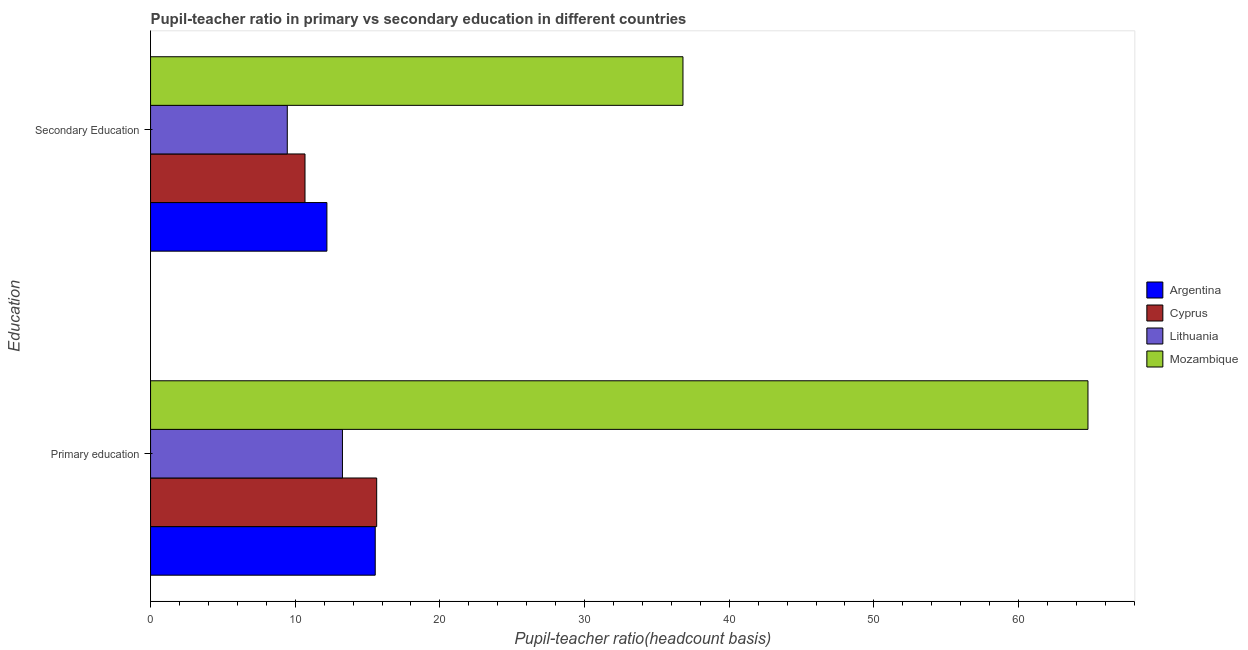Are the number of bars per tick equal to the number of legend labels?
Provide a short and direct response. Yes. Are the number of bars on each tick of the Y-axis equal?
Offer a terse response. Yes. How many bars are there on the 1st tick from the top?
Offer a terse response. 4. How many bars are there on the 2nd tick from the bottom?
Give a very brief answer. 4. What is the label of the 1st group of bars from the top?
Your answer should be compact. Secondary Education. What is the pupil-teacher ratio in primary education in Cyprus?
Provide a short and direct response. 15.63. Across all countries, what is the maximum pupil-teacher ratio in primary education?
Your answer should be very brief. 64.8. Across all countries, what is the minimum pupil-teacher ratio in primary education?
Ensure brevity in your answer.  13.26. In which country was the pupil teacher ratio on secondary education maximum?
Provide a succinct answer. Mozambique. In which country was the pupil teacher ratio on secondary education minimum?
Give a very brief answer. Lithuania. What is the total pupil-teacher ratio in primary education in the graph?
Offer a terse response. 109.22. What is the difference between the pupil-teacher ratio in primary education in Argentina and that in Cyprus?
Give a very brief answer. -0.1. What is the difference between the pupil teacher ratio on secondary education in Lithuania and the pupil-teacher ratio in primary education in Argentina?
Offer a very short reply. -6.08. What is the average pupil teacher ratio on secondary education per country?
Offer a very short reply. 17.28. What is the difference between the pupil-teacher ratio in primary education and pupil teacher ratio on secondary education in Mozambique?
Offer a terse response. 27.99. In how many countries, is the pupil-teacher ratio in primary education greater than 8 ?
Your response must be concise. 4. What is the ratio of the pupil teacher ratio on secondary education in Mozambique to that in Cyprus?
Give a very brief answer. 3.45. What does the 3rd bar from the top in Primary education represents?
Give a very brief answer. Cyprus. What does the 3rd bar from the bottom in Secondary Education represents?
Make the answer very short. Lithuania. How many bars are there?
Offer a terse response. 8. Are all the bars in the graph horizontal?
Provide a succinct answer. Yes. What is the difference between two consecutive major ticks on the X-axis?
Provide a succinct answer. 10. Does the graph contain grids?
Provide a succinct answer. No. Where does the legend appear in the graph?
Ensure brevity in your answer.  Center right. What is the title of the graph?
Give a very brief answer. Pupil-teacher ratio in primary vs secondary education in different countries. What is the label or title of the X-axis?
Your answer should be compact. Pupil-teacher ratio(headcount basis). What is the label or title of the Y-axis?
Your response must be concise. Education. What is the Pupil-teacher ratio(headcount basis) of Argentina in Primary education?
Your response must be concise. 15.53. What is the Pupil-teacher ratio(headcount basis) in Cyprus in Primary education?
Your answer should be compact. 15.63. What is the Pupil-teacher ratio(headcount basis) of Lithuania in Primary education?
Make the answer very short. 13.26. What is the Pupil-teacher ratio(headcount basis) in Mozambique in Primary education?
Offer a very short reply. 64.8. What is the Pupil-teacher ratio(headcount basis) in Argentina in Secondary Education?
Your response must be concise. 12.19. What is the Pupil-teacher ratio(headcount basis) of Cyprus in Secondary Education?
Make the answer very short. 10.68. What is the Pupil-teacher ratio(headcount basis) of Lithuania in Secondary Education?
Provide a succinct answer. 9.45. What is the Pupil-teacher ratio(headcount basis) of Mozambique in Secondary Education?
Your answer should be very brief. 36.8. Across all Education, what is the maximum Pupil-teacher ratio(headcount basis) of Argentina?
Offer a very short reply. 15.53. Across all Education, what is the maximum Pupil-teacher ratio(headcount basis) in Cyprus?
Offer a very short reply. 15.63. Across all Education, what is the maximum Pupil-teacher ratio(headcount basis) in Lithuania?
Make the answer very short. 13.26. Across all Education, what is the maximum Pupil-teacher ratio(headcount basis) in Mozambique?
Keep it short and to the point. 64.8. Across all Education, what is the minimum Pupil-teacher ratio(headcount basis) of Argentina?
Your answer should be compact. 12.19. Across all Education, what is the minimum Pupil-teacher ratio(headcount basis) in Cyprus?
Offer a very short reply. 10.68. Across all Education, what is the minimum Pupil-teacher ratio(headcount basis) of Lithuania?
Your answer should be compact. 9.45. Across all Education, what is the minimum Pupil-teacher ratio(headcount basis) in Mozambique?
Keep it short and to the point. 36.8. What is the total Pupil-teacher ratio(headcount basis) of Argentina in the graph?
Give a very brief answer. 27.72. What is the total Pupil-teacher ratio(headcount basis) of Cyprus in the graph?
Offer a very short reply. 26.31. What is the total Pupil-teacher ratio(headcount basis) of Lithuania in the graph?
Make the answer very short. 22.71. What is the total Pupil-teacher ratio(headcount basis) in Mozambique in the graph?
Offer a very short reply. 101.6. What is the difference between the Pupil-teacher ratio(headcount basis) in Argentina in Primary education and that in Secondary Education?
Ensure brevity in your answer.  3.34. What is the difference between the Pupil-teacher ratio(headcount basis) of Cyprus in Primary education and that in Secondary Education?
Provide a succinct answer. 4.95. What is the difference between the Pupil-teacher ratio(headcount basis) of Lithuania in Primary education and that in Secondary Education?
Provide a short and direct response. 3.81. What is the difference between the Pupil-teacher ratio(headcount basis) of Mozambique in Primary education and that in Secondary Education?
Give a very brief answer. 27.99. What is the difference between the Pupil-teacher ratio(headcount basis) of Argentina in Primary education and the Pupil-teacher ratio(headcount basis) of Cyprus in Secondary Education?
Your answer should be compact. 4.85. What is the difference between the Pupil-teacher ratio(headcount basis) in Argentina in Primary education and the Pupil-teacher ratio(headcount basis) in Lithuania in Secondary Education?
Offer a very short reply. 6.08. What is the difference between the Pupil-teacher ratio(headcount basis) of Argentina in Primary education and the Pupil-teacher ratio(headcount basis) of Mozambique in Secondary Education?
Your answer should be compact. -21.27. What is the difference between the Pupil-teacher ratio(headcount basis) in Cyprus in Primary education and the Pupil-teacher ratio(headcount basis) in Lithuania in Secondary Education?
Give a very brief answer. 6.18. What is the difference between the Pupil-teacher ratio(headcount basis) of Cyprus in Primary education and the Pupil-teacher ratio(headcount basis) of Mozambique in Secondary Education?
Your response must be concise. -21.17. What is the difference between the Pupil-teacher ratio(headcount basis) in Lithuania in Primary education and the Pupil-teacher ratio(headcount basis) in Mozambique in Secondary Education?
Offer a very short reply. -23.54. What is the average Pupil-teacher ratio(headcount basis) in Argentina per Education?
Offer a very short reply. 13.86. What is the average Pupil-teacher ratio(headcount basis) of Cyprus per Education?
Offer a terse response. 13.15. What is the average Pupil-teacher ratio(headcount basis) of Lithuania per Education?
Ensure brevity in your answer.  11.36. What is the average Pupil-teacher ratio(headcount basis) of Mozambique per Education?
Your answer should be very brief. 50.8. What is the difference between the Pupil-teacher ratio(headcount basis) in Argentina and Pupil-teacher ratio(headcount basis) in Cyprus in Primary education?
Your response must be concise. -0.1. What is the difference between the Pupil-teacher ratio(headcount basis) in Argentina and Pupil-teacher ratio(headcount basis) in Lithuania in Primary education?
Provide a short and direct response. 2.27. What is the difference between the Pupil-teacher ratio(headcount basis) in Argentina and Pupil-teacher ratio(headcount basis) in Mozambique in Primary education?
Your answer should be compact. -49.27. What is the difference between the Pupil-teacher ratio(headcount basis) of Cyprus and Pupil-teacher ratio(headcount basis) of Lithuania in Primary education?
Provide a short and direct response. 2.37. What is the difference between the Pupil-teacher ratio(headcount basis) of Cyprus and Pupil-teacher ratio(headcount basis) of Mozambique in Primary education?
Offer a very short reply. -49.17. What is the difference between the Pupil-teacher ratio(headcount basis) in Lithuania and Pupil-teacher ratio(headcount basis) in Mozambique in Primary education?
Your answer should be compact. -51.53. What is the difference between the Pupil-teacher ratio(headcount basis) in Argentina and Pupil-teacher ratio(headcount basis) in Cyprus in Secondary Education?
Offer a terse response. 1.51. What is the difference between the Pupil-teacher ratio(headcount basis) in Argentina and Pupil-teacher ratio(headcount basis) in Lithuania in Secondary Education?
Provide a succinct answer. 2.74. What is the difference between the Pupil-teacher ratio(headcount basis) in Argentina and Pupil-teacher ratio(headcount basis) in Mozambique in Secondary Education?
Your answer should be compact. -24.61. What is the difference between the Pupil-teacher ratio(headcount basis) in Cyprus and Pupil-teacher ratio(headcount basis) in Lithuania in Secondary Education?
Keep it short and to the point. 1.23. What is the difference between the Pupil-teacher ratio(headcount basis) of Cyprus and Pupil-teacher ratio(headcount basis) of Mozambique in Secondary Education?
Your answer should be very brief. -26.13. What is the difference between the Pupil-teacher ratio(headcount basis) of Lithuania and Pupil-teacher ratio(headcount basis) of Mozambique in Secondary Education?
Your answer should be compact. -27.35. What is the ratio of the Pupil-teacher ratio(headcount basis) of Argentina in Primary education to that in Secondary Education?
Provide a short and direct response. 1.27. What is the ratio of the Pupil-teacher ratio(headcount basis) of Cyprus in Primary education to that in Secondary Education?
Your response must be concise. 1.46. What is the ratio of the Pupil-teacher ratio(headcount basis) of Lithuania in Primary education to that in Secondary Education?
Provide a succinct answer. 1.4. What is the ratio of the Pupil-teacher ratio(headcount basis) of Mozambique in Primary education to that in Secondary Education?
Provide a succinct answer. 1.76. What is the difference between the highest and the second highest Pupil-teacher ratio(headcount basis) of Argentina?
Provide a succinct answer. 3.34. What is the difference between the highest and the second highest Pupil-teacher ratio(headcount basis) of Cyprus?
Make the answer very short. 4.95. What is the difference between the highest and the second highest Pupil-teacher ratio(headcount basis) in Lithuania?
Provide a succinct answer. 3.81. What is the difference between the highest and the second highest Pupil-teacher ratio(headcount basis) of Mozambique?
Your response must be concise. 27.99. What is the difference between the highest and the lowest Pupil-teacher ratio(headcount basis) of Argentina?
Provide a succinct answer. 3.34. What is the difference between the highest and the lowest Pupil-teacher ratio(headcount basis) in Cyprus?
Provide a succinct answer. 4.95. What is the difference between the highest and the lowest Pupil-teacher ratio(headcount basis) of Lithuania?
Make the answer very short. 3.81. What is the difference between the highest and the lowest Pupil-teacher ratio(headcount basis) in Mozambique?
Your answer should be very brief. 27.99. 